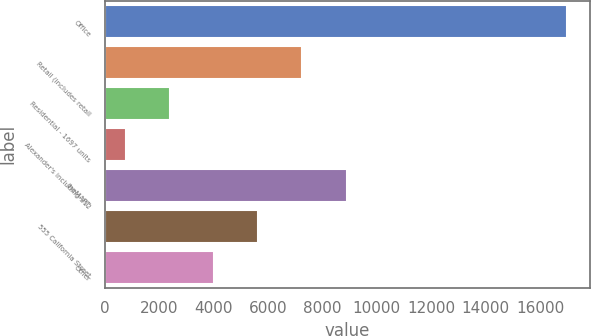<chart> <loc_0><loc_0><loc_500><loc_500><bar_chart><fcel>Office<fcel>Retail (includes retail<fcel>Residential - 1697 units<fcel>Alexander's including 312<fcel>theMART<fcel>555 California Street<fcel>Other<nl><fcel>16982<fcel>7266.8<fcel>2409.2<fcel>790<fcel>8886<fcel>5647.6<fcel>4028.4<nl></chart> 